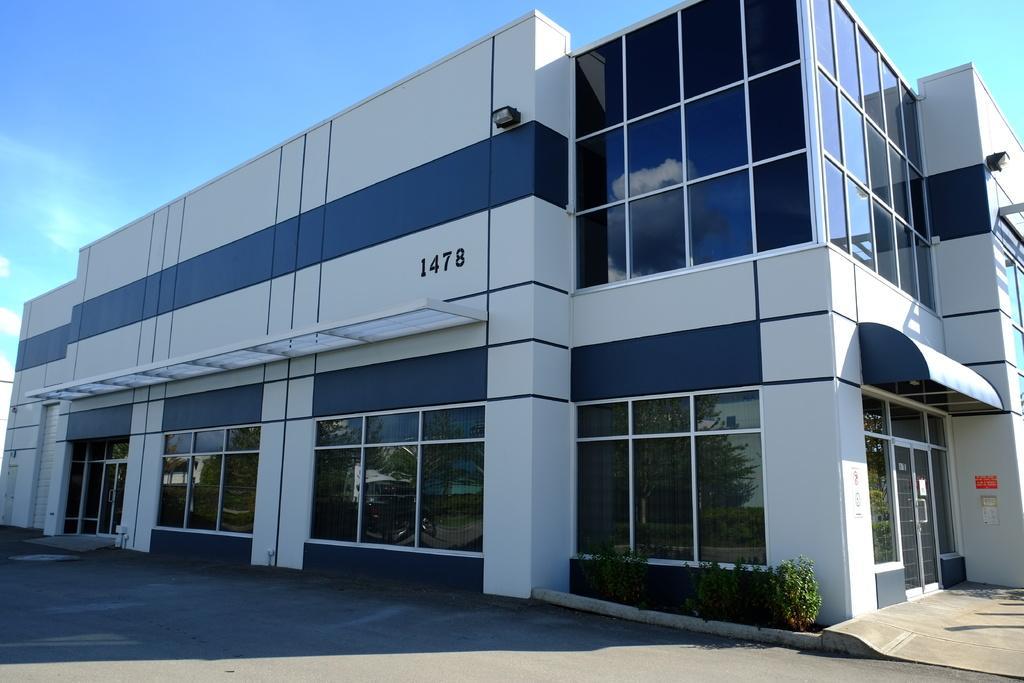How would you summarize this image in a sentence or two? In this picture we can see a building with windows and doors, trees, path and in the background we can see sky with clouds. 